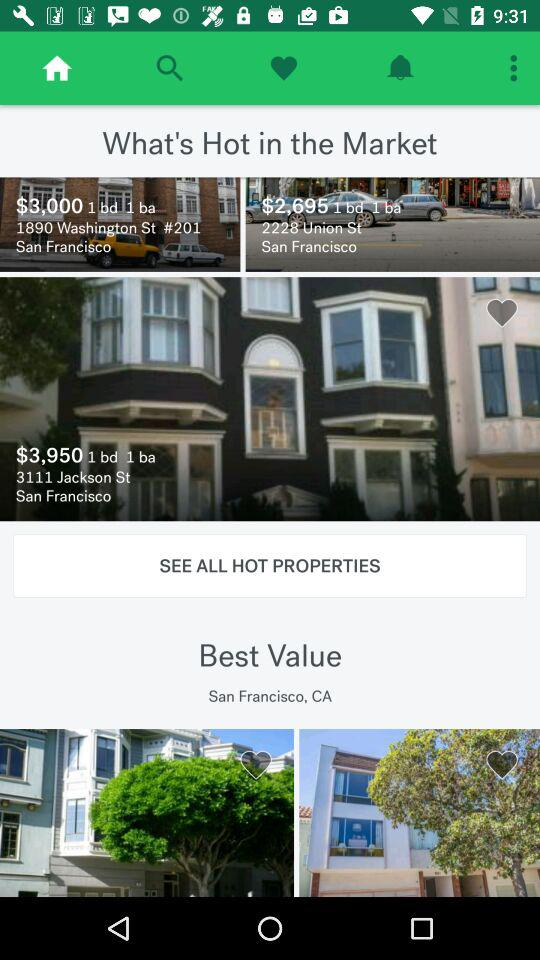How many houses are liked as favorites?
When the provided information is insufficient, respond with <no answer>. <no answer> 